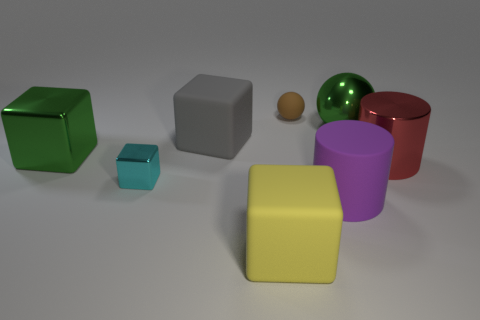There is a red thing that is the same size as the purple matte thing; what shape is it?
Keep it short and to the point. Cylinder. There is another cylinder that is the same size as the metal cylinder; what is its material?
Offer a very short reply. Rubber. Is the size of the matte cube that is to the left of the big yellow object the same as the cyan object in front of the small brown rubber object?
Your answer should be very brief. No. There is a tiny brown rubber sphere; are there any rubber cubes behind it?
Give a very brief answer. No. What is the color of the small thing in front of the thing to the right of the large green metallic sphere?
Your answer should be compact. Cyan. Is the number of brown spheres less than the number of big red spheres?
Provide a succinct answer. No. How many other objects have the same shape as the gray rubber thing?
Keep it short and to the point. 3. The metallic ball that is the same size as the metallic cylinder is what color?
Your answer should be very brief. Green. Are there an equal number of cyan blocks in front of the purple matte cylinder and small brown matte balls that are to the right of the red shiny cylinder?
Make the answer very short. Yes. Are there any objects of the same size as the brown matte sphere?
Ensure brevity in your answer.  Yes. 